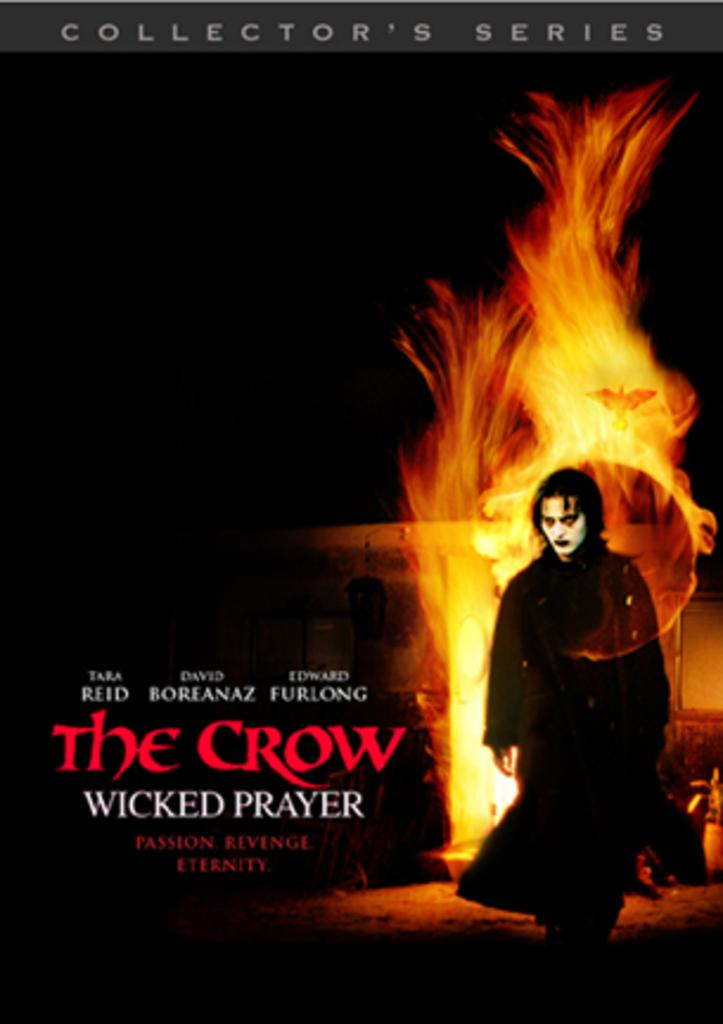<image>
Relay a brief, clear account of the picture shown. The Crow Wicked Prayer passon, revenge, and eternity collector's series. 